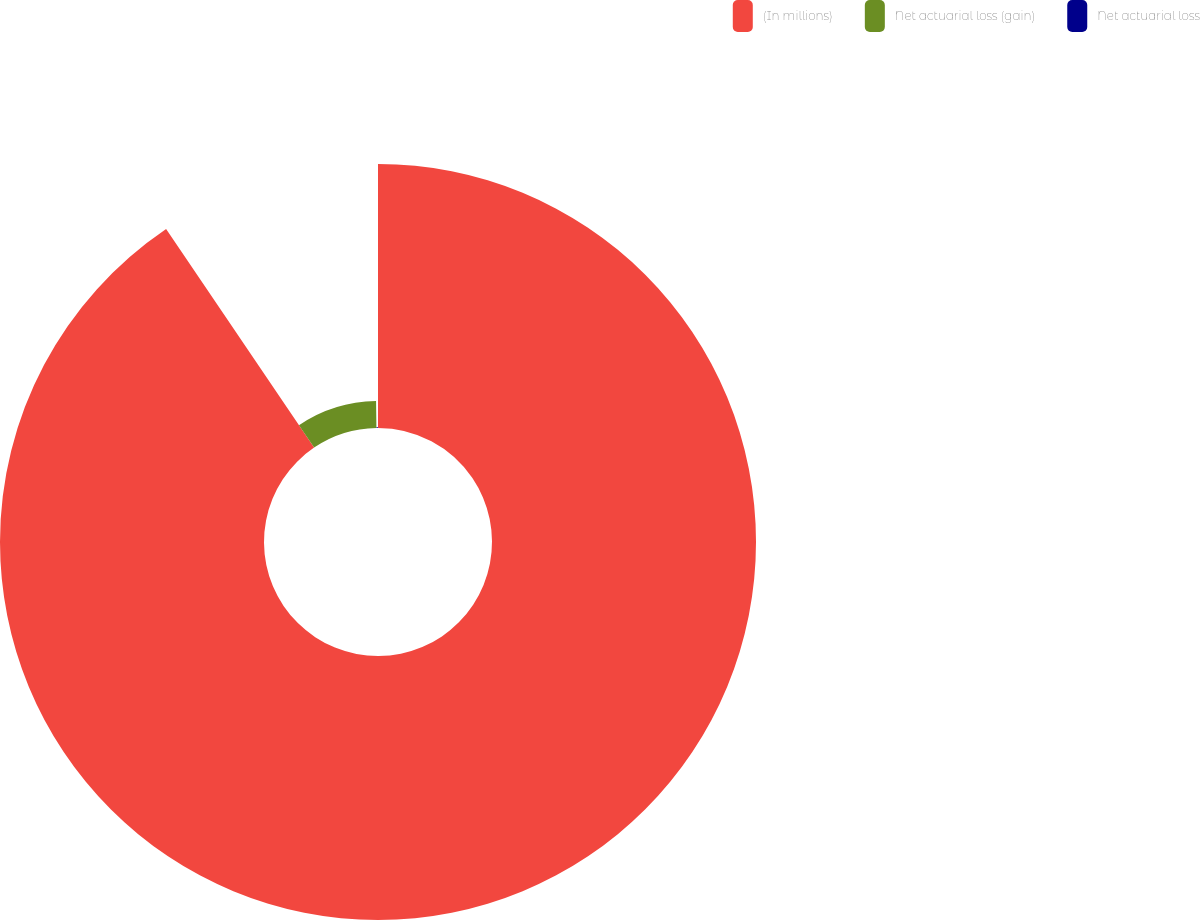Convert chart to OTSL. <chart><loc_0><loc_0><loc_500><loc_500><pie_chart><fcel>(In millions)<fcel>Net actuarial loss (gain)<fcel>Net actuarial loss<nl><fcel>90.52%<fcel>9.25%<fcel>0.22%<nl></chart> 